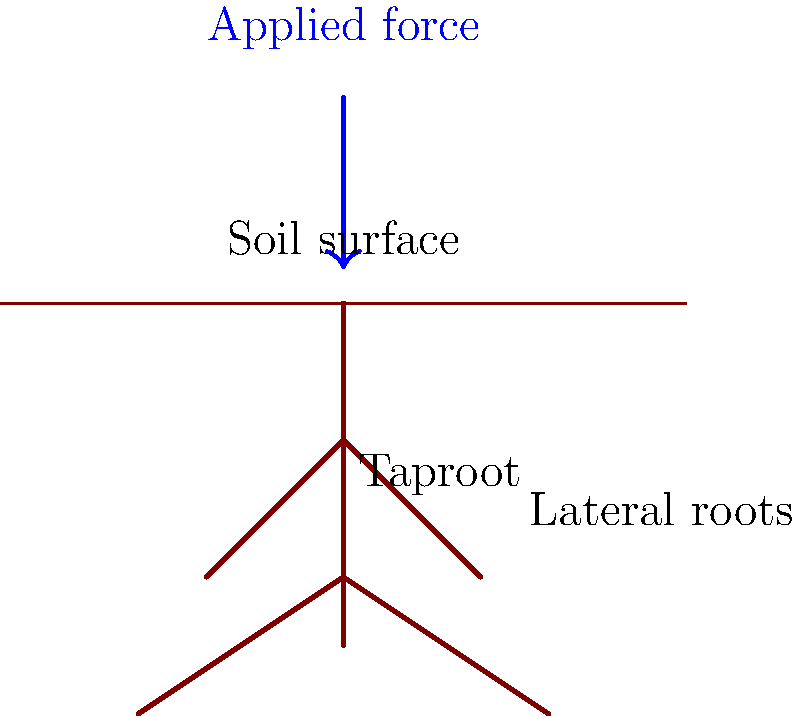Given the root structure of a mature oak tree shown in the diagram, estimate the force required to uproot it if the soil adhesion strength is 50 kPa and the total surface area of the roots is approximately 2 m². How does this compare to the force needed to uproot a smaller plant with a surface area of 0.5 m² in the same soil conditions? To solve this problem, we'll use the formula:

$F = P \times A$

Where:
$F$ = Force required to uproot the plant
$P$ = Soil adhesion strength
$A$ = Total surface area of the roots

Step 1: Calculate the force for the oak tree
$F_{oak} = 50 \text{ kPa} \times 2 \text{ m}^2$
$F_{oak} = 100 \text{ kN}$

Step 2: Calculate the force for the smaller plant
$F_{small} = 50 \text{ kPa} \times 0.5 \text{ m}^2$
$F_{small} = 25 \text{ kN}$

Step 3: Compare the forces
The ratio of forces is:
$$\frac{F_{oak}}{F_{small}} = \frac{100 \text{ kN}}{25 \text{ kN}} = 4$$

This means the force required to uproot the oak tree is 4 times greater than the force needed for the smaller plant.

The difference in force is:
$F_{oak} - F_{small} = 100 \text{ kN} - 25 \text{ kN} = 75 \text{ kN}$
Answer: Oak tree: 100 kN; Smaller plant: 25 kN; 4 times more force for oak; 75 kN difference 